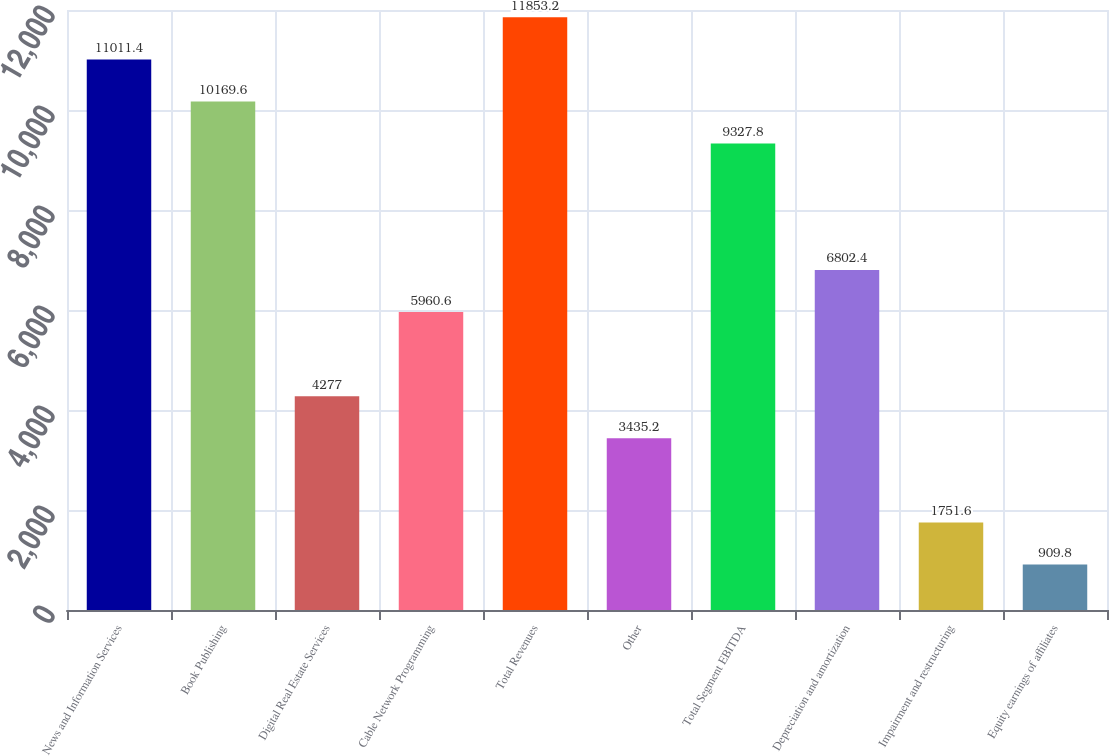Convert chart to OTSL. <chart><loc_0><loc_0><loc_500><loc_500><bar_chart><fcel>News and Information Services<fcel>Book Publishing<fcel>Digital Real Estate Services<fcel>Cable Network Programming<fcel>Total Revenues<fcel>Other<fcel>Total Segment EBITDA<fcel>Depreciation and amortization<fcel>Impairment and restructuring<fcel>Equity earnings of affiliates<nl><fcel>11011.4<fcel>10169.6<fcel>4277<fcel>5960.6<fcel>11853.2<fcel>3435.2<fcel>9327.8<fcel>6802.4<fcel>1751.6<fcel>909.8<nl></chart> 